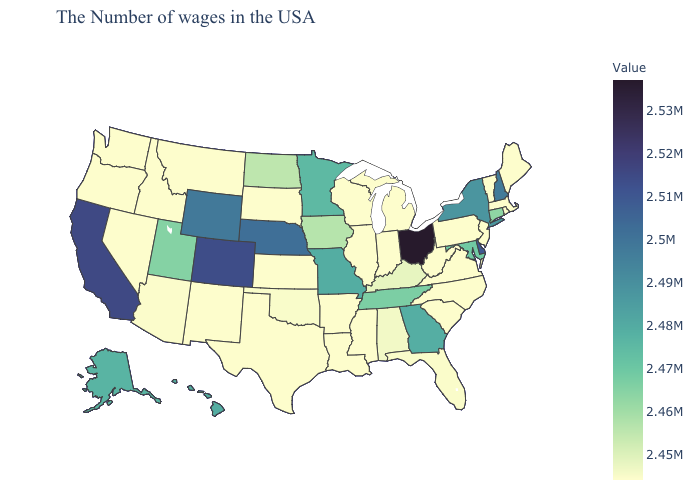Which states have the lowest value in the USA?
Quick response, please. Maine, Massachusetts, Rhode Island, Vermont, New Jersey, Pennsylvania, Virginia, North Carolina, South Carolina, West Virginia, Michigan, Indiana, Wisconsin, Illinois, Mississippi, Louisiana, Arkansas, Kansas, Texas, South Dakota, New Mexico, Montana, Idaho, Nevada, Washington, Oregon. Does New Hampshire have the highest value in the Northeast?
Concise answer only. Yes. 